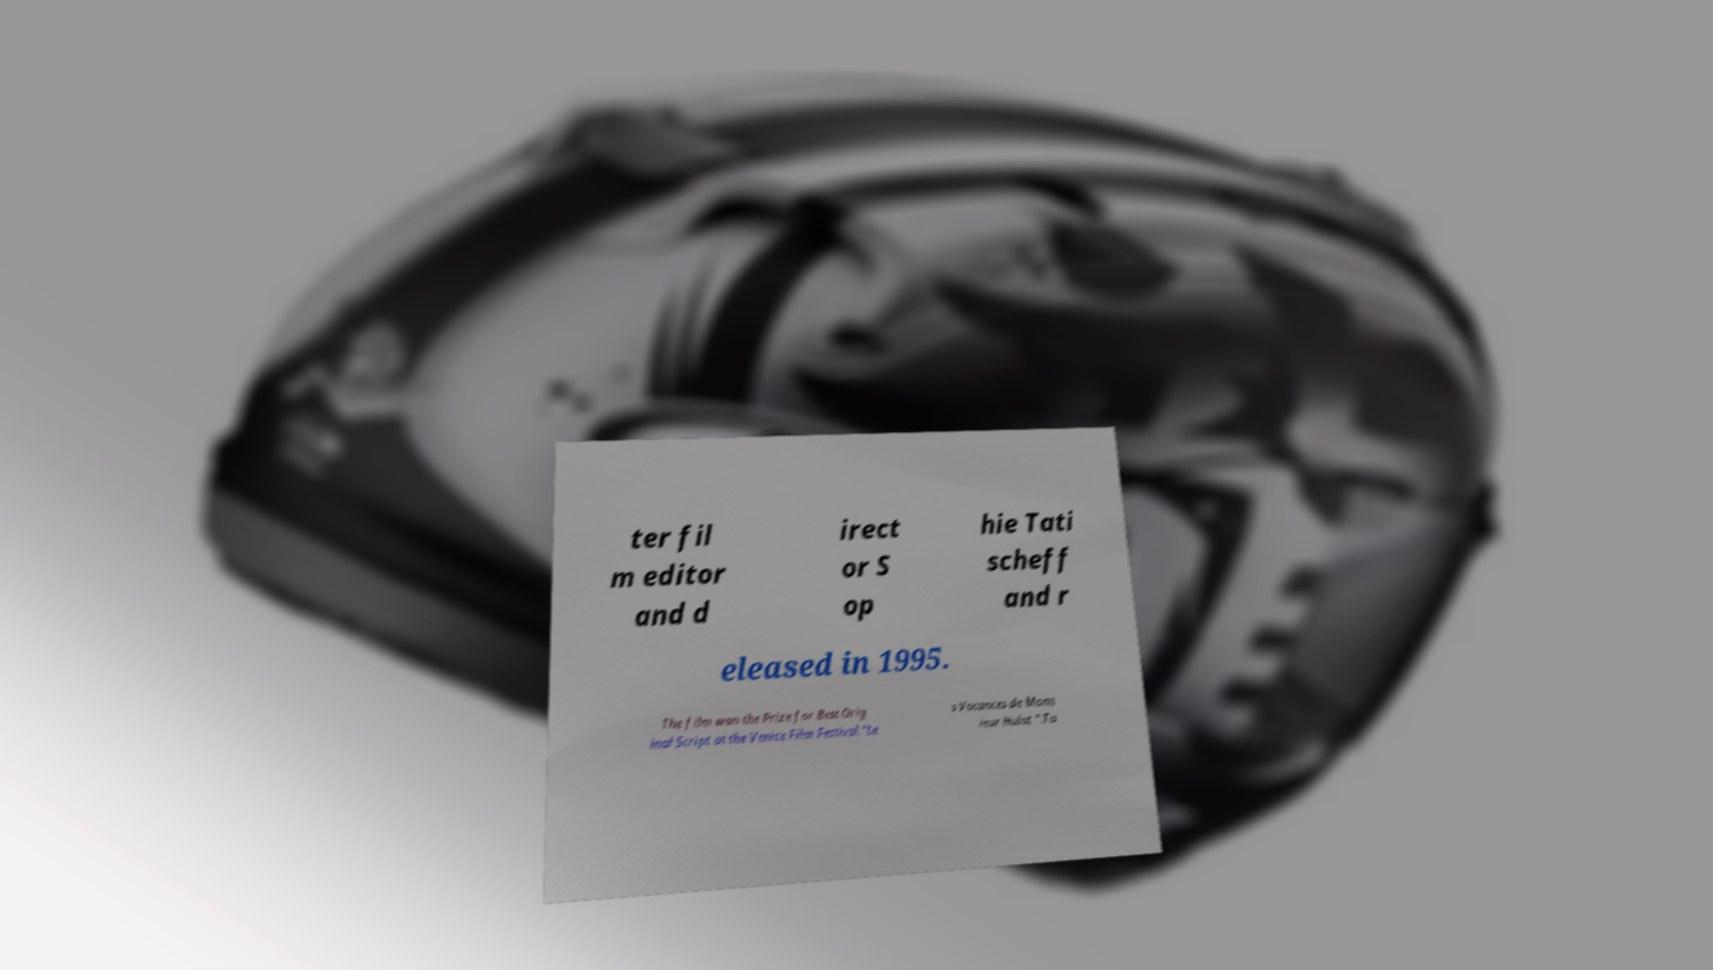I need the written content from this picture converted into text. Can you do that? ter fil m editor and d irect or S op hie Tati scheff and r eleased in 1995. The film won the Prize for Best Orig inal Script at the Venice Film Festival."Le s Vacances de Mons ieur Hulot ".Ta 